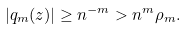Convert formula to latex. <formula><loc_0><loc_0><loc_500><loc_500>| q _ { m } ( z ) | \geq n ^ { - m } > n ^ { m } \rho _ { m } .</formula> 